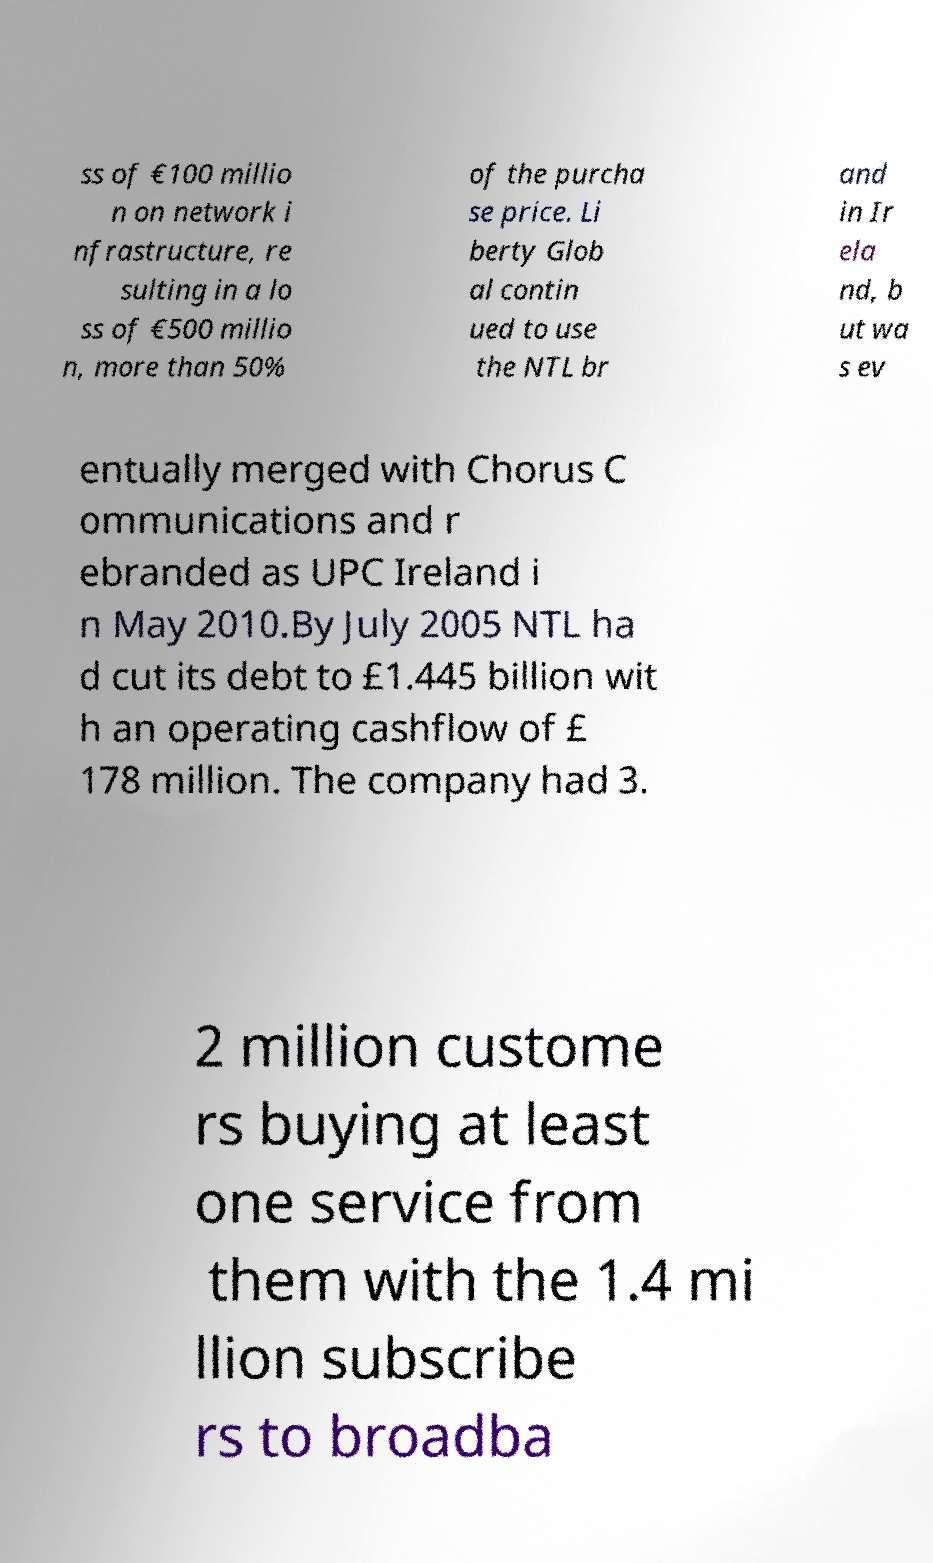Please read and relay the text visible in this image. What does it say? ss of €100 millio n on network i nfrastructure, re sulting in a lo ss of €500 millio n, more than 50% of the purcha se price. Li berty Glob al contin ued to use the NTL br and in Ir ela nd, b ut wa s ev entually merged with Chorus C ommunications and r ebranded as UPC Ireland i n May 2010.By July 2005 NTL ha d cut its debt to £1.445 billion wit h an operating cashflow of £ 178 million. The company had 3. 2 million custome rs buying at least one service from them with the 1.4 mi llion subscribe rs to broadba 